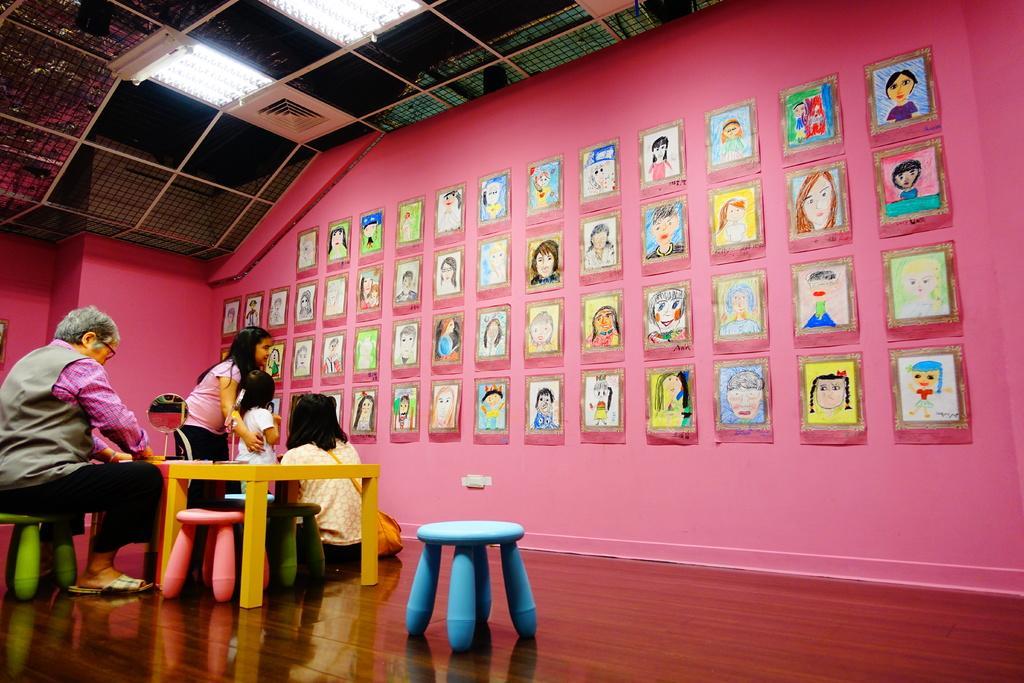Can you describe this image briefly? In the image we can see a man and a woman, they are sitting and two children are standing, they are wearing clothes. Here we can see stools, a table, wooden floor, wall and drawing papers are stick to the wall. Here we can see the lights and the roof. 